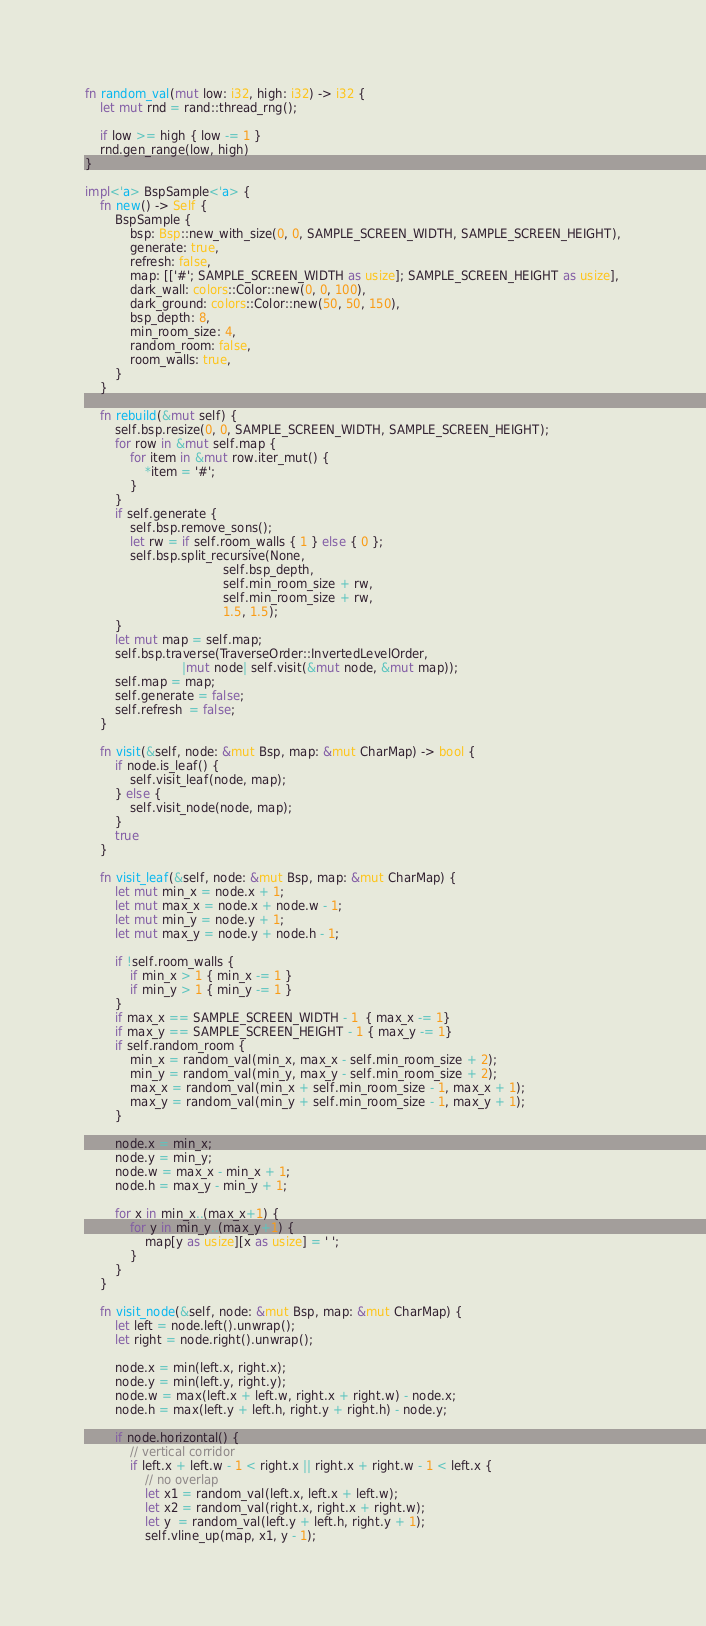Convert code to text. <code><loc_0><loc_0><loc_500><loc_500><_Rust_>fn random_val(mut low: i32, high: i32) -> i32 {
    let mut rnd = rand::thread_rng();

    if low >= high { low -= 1 }
    rnd.gen_range(low, high)
}

impl<'a> BspSample<'a> {
    fn new() -> Self {
        BspSample {
            bsp: Bsp::new_with_size(0, 0, SAMPLE_SCREEN_WIDTH, SAMPLE_SCREEN_HEIGHT),
            generate: true,
            refresh: false,
            map: [['#'; SAMPLE_SCREEN_WIDTH as usize]; SAMPLE_SCREEN_HEIGHT as usize],
            dark_wall: colors::Color::new(0, 0, 100),
            dark_ground: colors::Color::new(50, 50, 150),
            bsp_depth: 8,
            min_room_size: 4,
            random_room: false,
            room_walls: true,
        }
    }

    fn rebuild(&mut self) {
        self.bsp.resize(0, 0, SAMPLE_SCREEN_WIDTH, SAMPLE_SCREEN_HEIGHT);
        for row in &mut self.map {
            for item in &mut row.iter_mut() {
                *item = '#';
            }
        }
        if self.generate {
            self.bsp.remove_sons();
            let rw = if self.room_walls { 1 } else { 0 };
            self.bsp.split_recursive(None,
                                     self.bsp_depth,
                                     self.min_room_size + rw,
                                     self.min_room_size + rw,
                                     1.5, 1.5);
        }
        let mut map = self.map;
        self.bsp.traverse(TraverseOrder::InvertedLevelOrder,
                          |mut node| self.visit(&mut node, &mut map));
        self.map = map;
        self.generate = false;
        self.refresh  = false;
    }

    fn visit(&self, node: &mut Bsp, map: &mut CharMap) -> bool {
        if node.is_leaf() {
            self.visit_leaf(node, map);
        } else {
            self.visit_node(node, map);
        }
        true
    }

    fn visit_leaf(&self, node: &mut Bsp, map: &mut CharMap) {
        let mut min_x = node.x + 1;
        let mut max_x = node.x + node.w - 1;
        let mut min_y = node.y + 1;
        let mut max_y = node.y + node.h - 1;

        if !self.room_walls {
            if min_x > 1 { min_x -= 1 }
            if min_y > 1 { min_y -= 1 }
        }
        if max_x == SAMPLE_SCREEN_WIDTH - 1  { max_x -= 1}
        if max_y == SAMPLE_SCREEN_HEIGHT - 1 { max_y -= 1}
        if self.random_room {
            min_x = random_val(min_x, max_x - self.min_room_size + 2);
            min_y = random_val(min_y, max_y - self.min_room_size + 2);
            max_x = random_val(min_x + self.min_room_size - 1, max_x + 1);
            max_y = random_val(min_y + self.min_room_size - 1, max_y + 1);
        }

        node.x = min_x;
        node.y = min_y;
        node.w = max_x - min_x + 1;
        node.h = max_y - min_y + 1;

        for x in min_x..(max_x+1) {
            for y in min_y..(max_y+1) {
                map[y as usize][x as usize] = ' ';
            }
        }
    }

    fn visit_node(&self, node: &mut Bsp, map: &mut CharMap) {
        let left = node.left().unwrap();
        let right = node.right().unwrap();

        node.x = min(left.x, right.x);
        node.y = min(left.y, right.y);
        node.w = max(left.x + left.w, right.x + right.w) - node.x;
        node.h = max(left.y + left.h, right.y + right.h) - node.y;

        if node.horizontal() {
            // vertical corridor
            if left.x + left.w - 1 < right.x || right.x + right.w - 1 < left.x {
                // no overlap
                let x1 = random_val(left.x, left.x + left.w);
                let x2 = random_val(right.x, right.x + right.w);
                let y  = random_val(left.y + left.h, right.y + 1);
                self.vline_up(map, x1, y - 1);</code> 